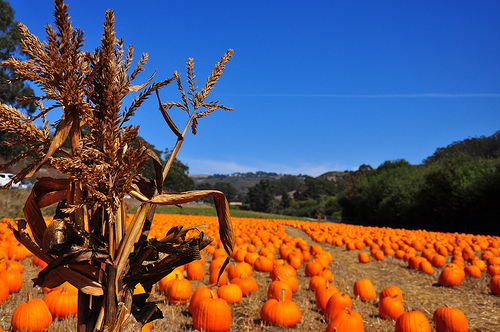<image>
Is there a pumpkin to the left of the corn stalk? No. The pumpkin is not to the left of the corn stalk. From this viewpoint, they have a different horizontal relationship. Is the sky behind the tree? Yes. From this viewpoint, the sky is positioned behind the tree, with the tree partially or fully occluding the sky. Is there a pumpkin next to the tree? Yes. The pumpkin is positioned adjacent to the tree, located nearby in the same general area. 